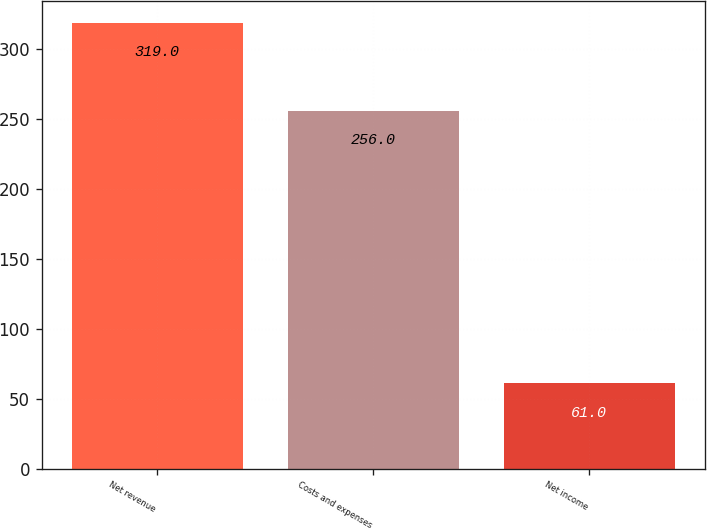Convert chart to OTSL. <chart><loc_0><loc_0><loc_500><loc_500><bar_chart><fcel>Net revenue<fcel>Costs and expenses<fcel>Net income<nl><fcel>319<fcel>256<fcel>61<nl></chart> 